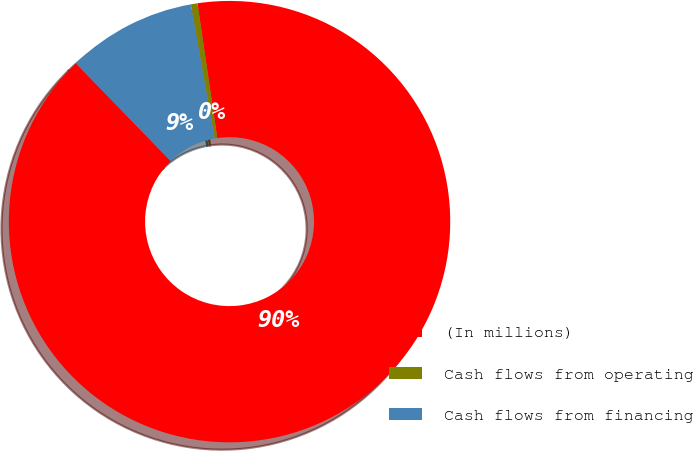Convert chart to OTSL. <chart><loc_0><loc_0><loc_500><loc_500><pie_chart><fcel>(In millions)<fcel>Cash flows from operating<fcel>Cash flows from financing<nl><fcel>90.06%<fcel>0.49%<fcel>9.45%<nl></chart> 